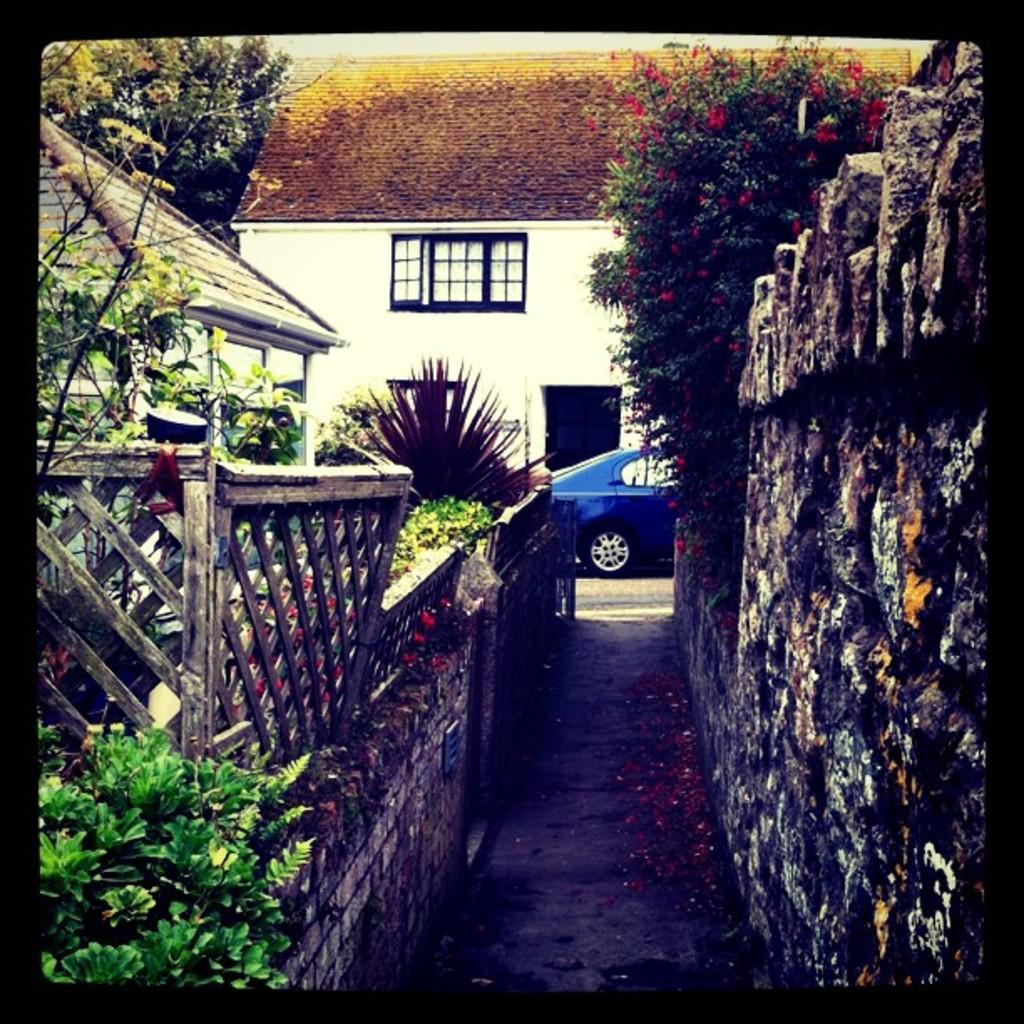What type of structures can be seen in the image? There are houses in the image. What type of vegetation is present in the image? There are plants, trees, and flowers in the image. What type of barrier can be seen in the image? There is a wooden fence in the image. What type of transportation is visible in the image? There is a vehicle in the image. What type of architectural feature can be seen in the image? There is a wall in the image. What type of silk is draped over the flowers in the image? There is no silk present in the image; it features houses, plants, trees, flowers, a wooden fence, a vehicle, and a wall. What message of hope can be seen in the image? There is no message of hope present in the image; it is a scene of houses, plants, trees, flowers, a wooden fence, a vehicle, and a wall. 